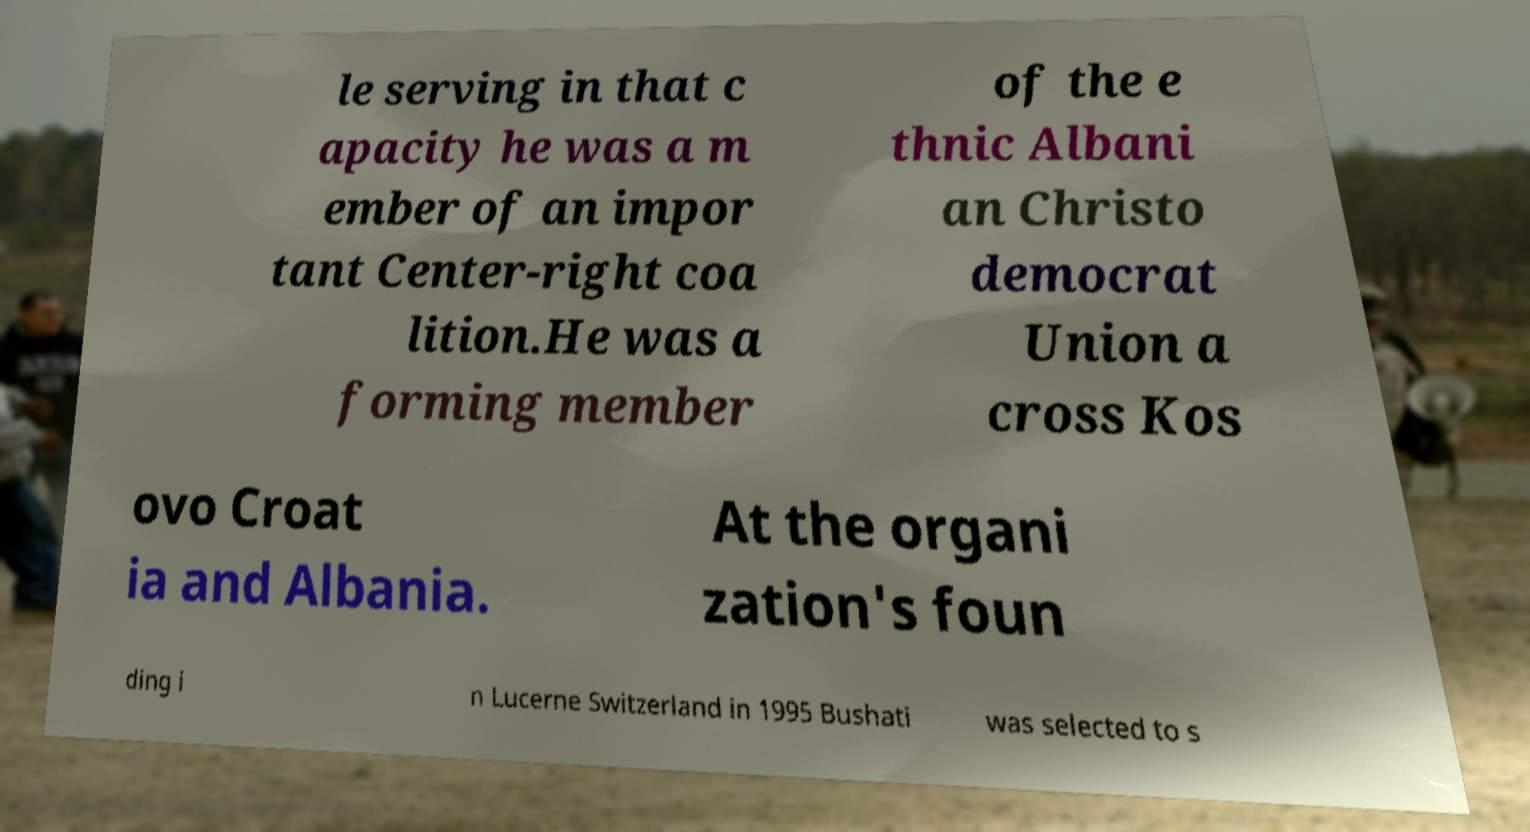There's text embedded in this image that I need extracted. Can you transcribe it verbatim? le serving in that c apacity he was a m ember of an impor tant Center-right coa lition.He was a forming member of the e thnic Albani an Christo democrat Union a cross Kos ovo Croat ia and Albania. At the organi zation's foun ding i n Lucerne Switzerland in 1995 Bushati was selected to s 